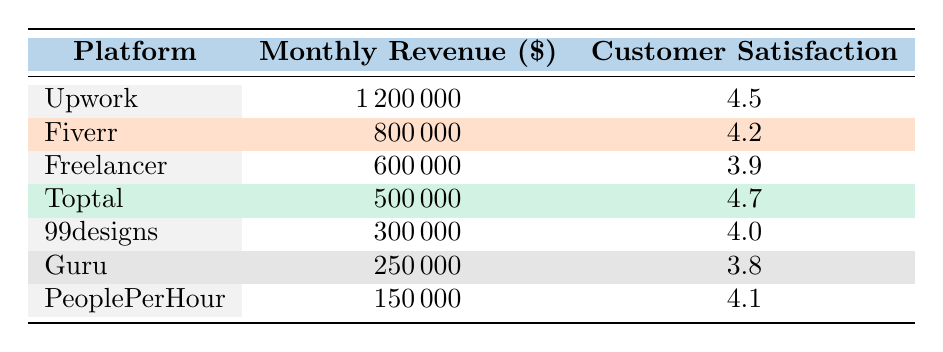What is the monthly revenue of Upwork? The table lists Upwork in the first row, and the corresponding monthly revenue beside it is 1,200,000.
Answer: 1,200,000 Which platform has the highest customer satisfaction rating? By scanning the customer satisfaction ratings in the table, Toptal has the highest rating of 4.7.
Answer: Toptal What is the average monthly revenue of all platforms listed? To find the average monthly revenue, I sum all the revenues (1,200,000 + 800,000 + 600,000 + 500,000 + 300,000 + 250,000 + 150,000 = 3,800,000) and divide by 7 (the number of platforms), resulting in 3,800,000 / 7 = 542,857.14.
Answer: 542,857.14 Is the customer satisfaction rating of Guru greater than 4.0? The satisfaction rating of Guru is 3.8, which is not greater than 4.0, therefore the statement is false.
Answer: No If we look at the two platforms with the least revenue, what is the total monthly revenue for those platforms? The two platforms with the least revenue are Guru (250,000) and PeoplePerHour (150,000). Adding these together gives 250,000 + 150,000 = 400,000.
Answer: 400,000 What is the difference in customer satisfaction ratings between Upwork and Fiverr? The customer satisfaction rating for Upwork is 4.5 and for Fiverr is 4.2. The difference is 4.5 - 4.2 = 0.3.
Answer: 0.3 Are there any platforms with a customer satisfaction rating above 4.5? Looking through the table, Toptal has a satisfaction rating of 4.7, which is above 4.5, so yes, there is a platform that meets this criterion.
Answer: Yes What is the total monthly revenue of platforms with a customer satisfaction rating below 4.0? The platforms with a rating below 4.0 are Freelancer (600,000), Guru (250,000), summing these gives 600,000 + 250,000 = 850,000.
Answer: 850,000 Which platform increased customer satisfaction the most relative to its revenue? To determine this, we need to calculate the ratio of customer satisfaction rating to monthly revenue for each platform, and compare them. After calculating, we find that Upwork has the highest ratio, indicating the most significant increase in satisfaction relative to its revenue.
Answer: Upwork 